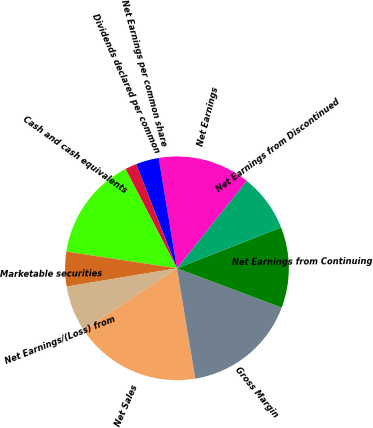Convert chart to OTSL. <chart><loc_0><loc_0><loc_500><loc_500><pie_chart><fcel>Net Sales<fcel>Gross Margin<fcel>Net Earnings from Continuing<fcel>Net Earnings from Discontinued<fcel>Net Earnings<fcel>Net Earnings per common share<fcel>Dividends declared per common<fcel>Cash and cash equivalents<fcel>Marketable securities<fcel>Net Earnings/(Loss) from<nl><fcel>18.33%<fcel>16.67%<fcel>11.67%<fcel>8.33%<fcel>13.33%<fcel>3.33%<fcel>1.67%<fcel>15.0%<fcel>5.0%<fcel>6.67%<nl></chart> 